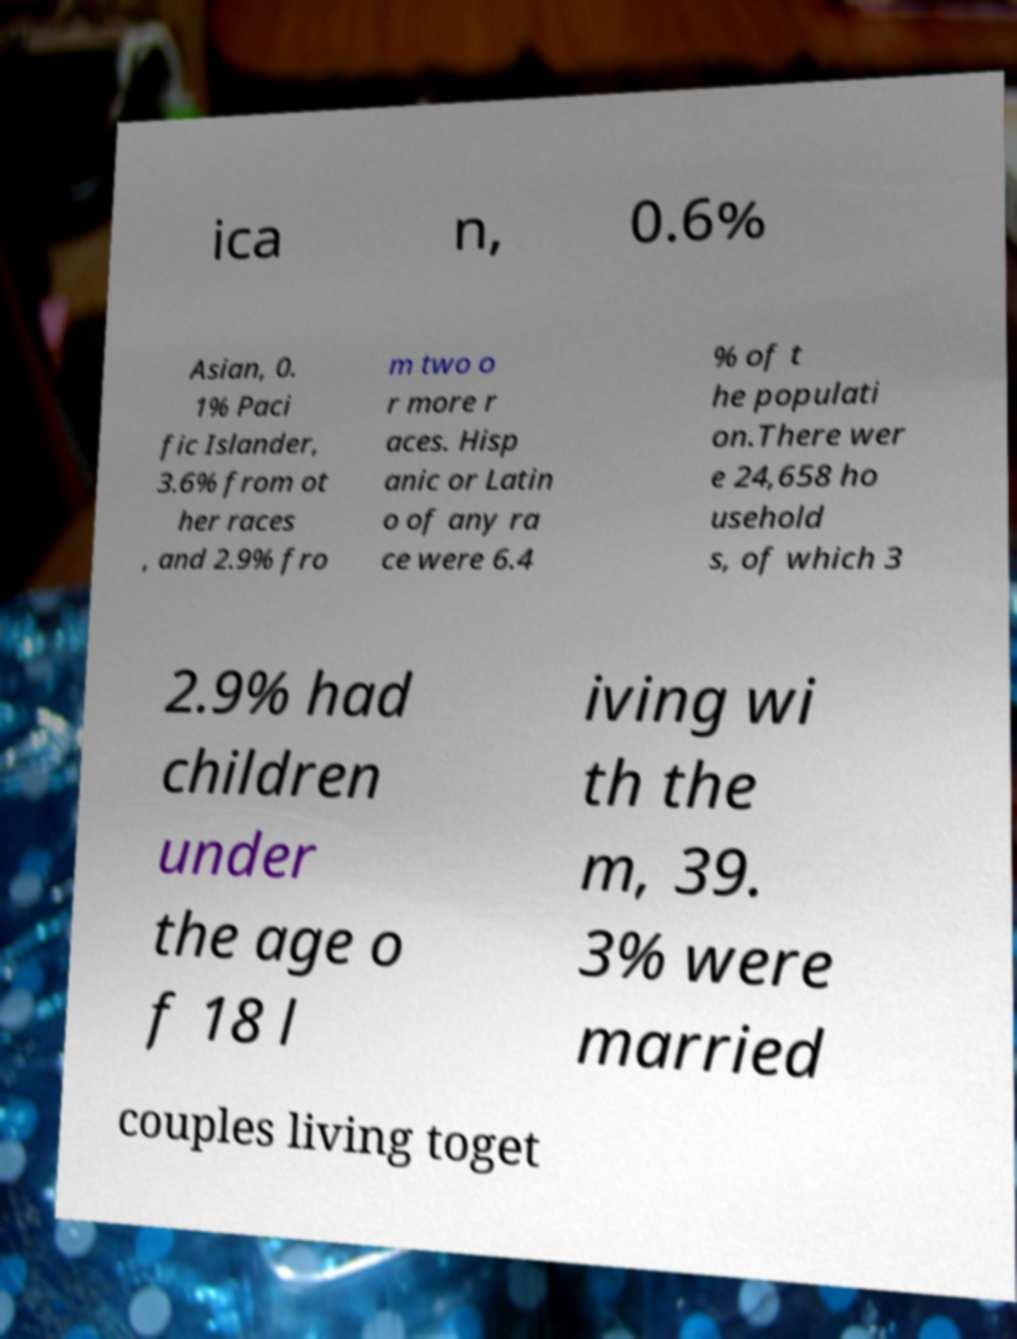I need the written content from this picture converted into text. Can you do that? ica n, 0.6% Asian, 0. 1% Paci fic Islander, 3.6% from ot her races , and 2.9% fro m two o r more r aces. Hisp anic or Latin o of any ra ce were 6.4 % of t he populati on.There wer e 24,658 ho usehold s, of which 3 2.9% had children under the age o f 18 l iving wi th the m, 39. 3% were married couples living toget 